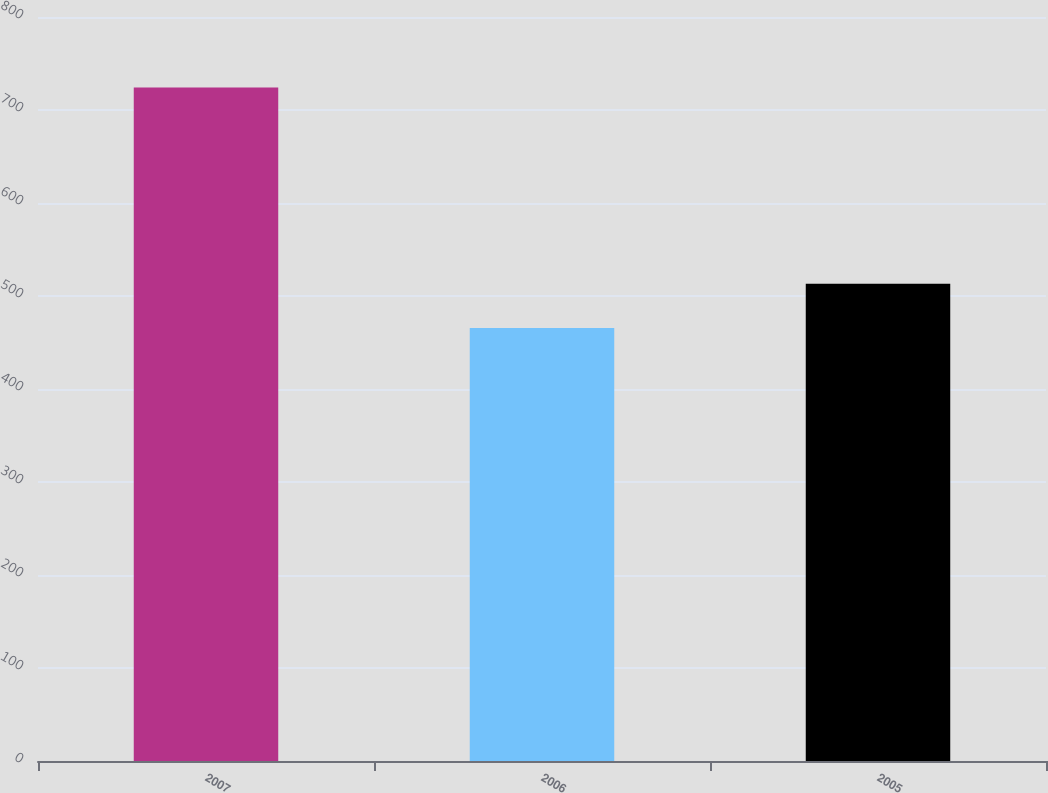Convert chart. <chart><loc_0><loc_0><loc_500><loc_500><bar_chart><fcel>2007<fcel>2006<fcel>2005<nl><fcel>724.1<fcel>465.5<fcel>513.3<nl></chart> 